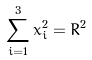<formula> <loc_0><loc_0><loc_500><loc_500>\sum _ { i = 1 } ^ { 3 } x _ { i } ^ { 2 } = R ^ { 2 }</formula> 